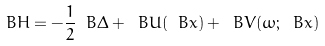Convert formula to latex. <formula><loc_0><loc_0><loc_500><loc_500>\ B { H } = - \frac { 1 } { 2 } \ B { \Delta } + \ B { U } ( \ B { x } ) + \ B { V } ( \omega ; \ B { x } )</formula> 